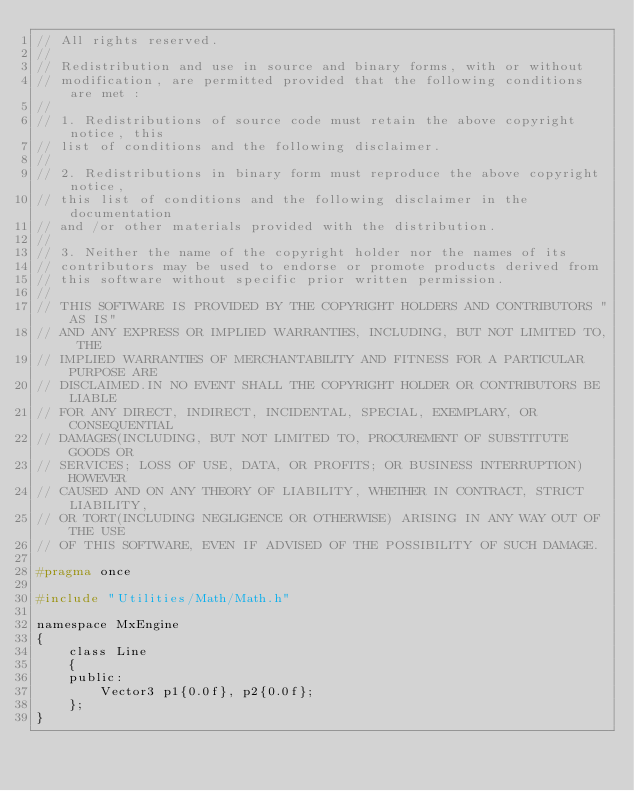Convert code to text. <code><loc_0><loc_0><loc_500><loc_500><_C_>// All rights reserved.
// 
// Redistribution and use in source and binary forms, with or without
// modification, are permitted provided that the following conditions are met :
// 
// 1. Redistributions of source code must retain the above copyright notice, this
// list of conditions and the following disclaimer.
// 
// 2. Redistributions in binary form must reproduce the above copyright notice,
// this list of conditions and the following disclaimer in the documentation
// and /or other materials provided with the distribution.
// 
// 3. Neither the name of the copyright holder nor the names of its
// contributors may be used to endorse or promote products derived from
// this software without specific prior written permission.
// 
// THIS SOFTWARE IS PROVIDED BY THE COPYRIGHT HOLDERS AND CONTRIBUTORS "AS IS"
// AND ANY EXPRESS OR IMPLIED WARRANTIES, INCLUDING, BUT NOT LIMITED TO, THE
// IMPLIED WARRANTIES OF MERCHANTABILITY AND FITNESS FOR A PARTICULAR PURPOSE ARE
// DISCLAIMED.IN NO EVENT SHALL THE COPYRIGHT HOLDER OR CONTRIBUTORS BE LIABLE
// FOR ANY DIRECT, INDIRECT, INCIDENTAL, SPECIAL, EXEMPLARY, OR CONSEQUENTIAL
// DAMAGES(INCLUDING, BUT NOT LIMITED TO, PROCUREMENT OF SUBSTITUTE GOODS OR
// SERVICES; LOSS OF USE, DATA, OR PROFITS; OR BUSINESS INTERRUPTION) HOWEVER
// CAUSED AND ON ANY THEORY OF LIABILITY, WHETHER IN CONTRACT, STRICT LIABILITY,
// OR TORT(INCLUDING NEGLIGENCE OR OTHERWISE) ARISING IN ANY WAY OUT OF THE USE
// OF THIS SOFTWARE, EVEN IF ADVISED OF THE POSSIBILITY OF SUCH DAMAGE.

#pragma once

#include "Utilities/Math/Math.h"

namespace MxEngine
{
    class Line
    {
    public:
        Vector3 p1{0.0f}, p2{0.0f};
    };
}</code> 